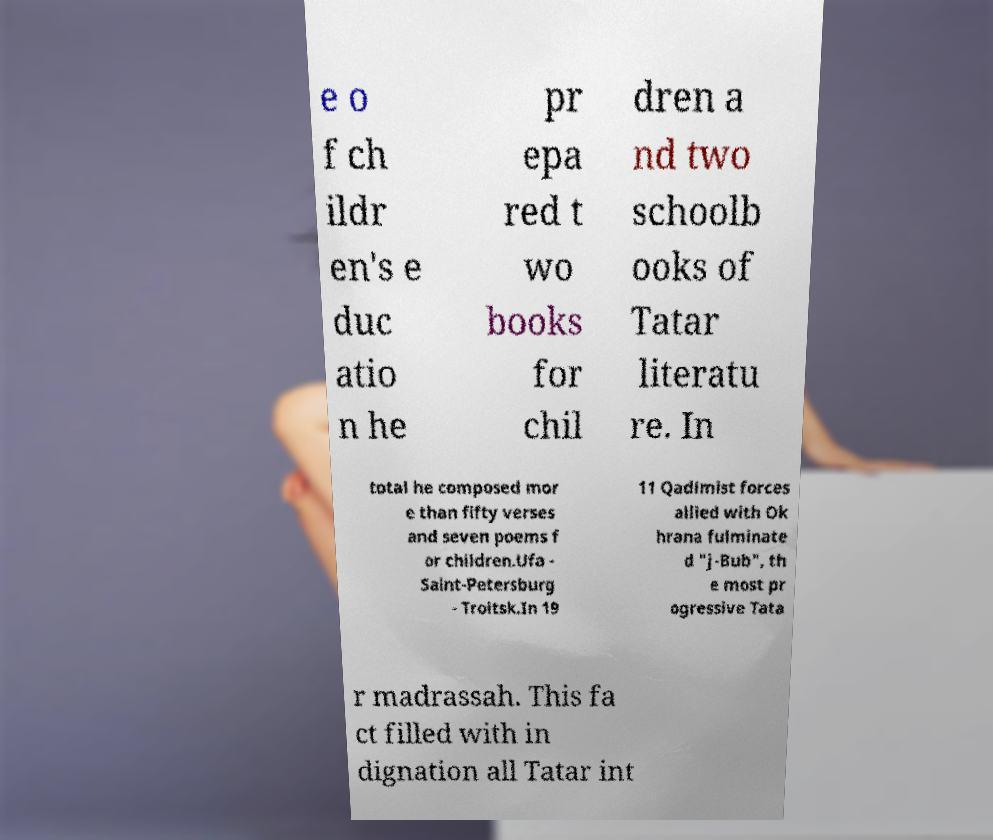For documentation purposes, I need the text within this image transcribed. Could you provide that? e o f ch ildr en's e duc atio n he pr epa red t wo books for chil dren a nd two schoolb ooks of Tatar literatu re. In total he composed mor e than fifty verses and seven poems f or children.Ufa - Saint-Petersburg - Troitsk.In 19 11 Qadimist forces allied with Ok hrana fulminate d "j-Bub", th e most pr ogressive Tata r madrassah. This fa ct filled with in dignation all Tatar int 